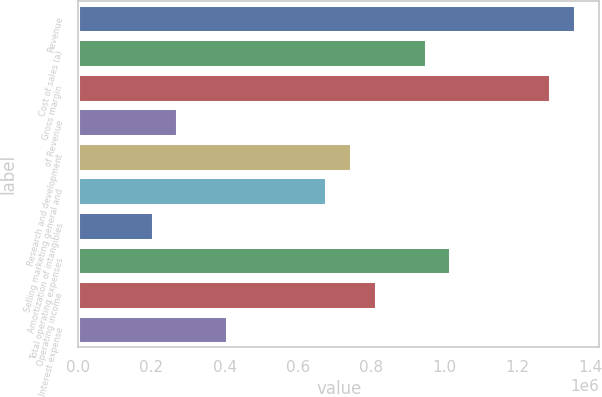Convert chart. <chart><loc_0><loc_0><loc_500><loc_500><bar_chart><fcel>Revenue<fcel>Cost of sales (a)<fcel>Gross margin<fcel>of Revenue<fcel>Research and development<fcel>Selling marketing general and<fcel>Amortization of intangibles<fcel>Total operating expenses<fcel>Operating income<fcel>Interest expense<nl><fcel>1.35627e+06<fcel>949386<fcel>1.28845e+06<fcel>271253<fcel>745946<fcel>678133<fcel>203440<fcel>1.0172e+06<fcel>813760<fcel>406880<nl></chart> 